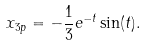Convert formula to latex. <formula><loc_0><loc_0><loc_500><loc_500>x _ { 3 p } = - { \frac { 1 } { 3 } } e ^ { - t } \sin ( t ) .</formula> 